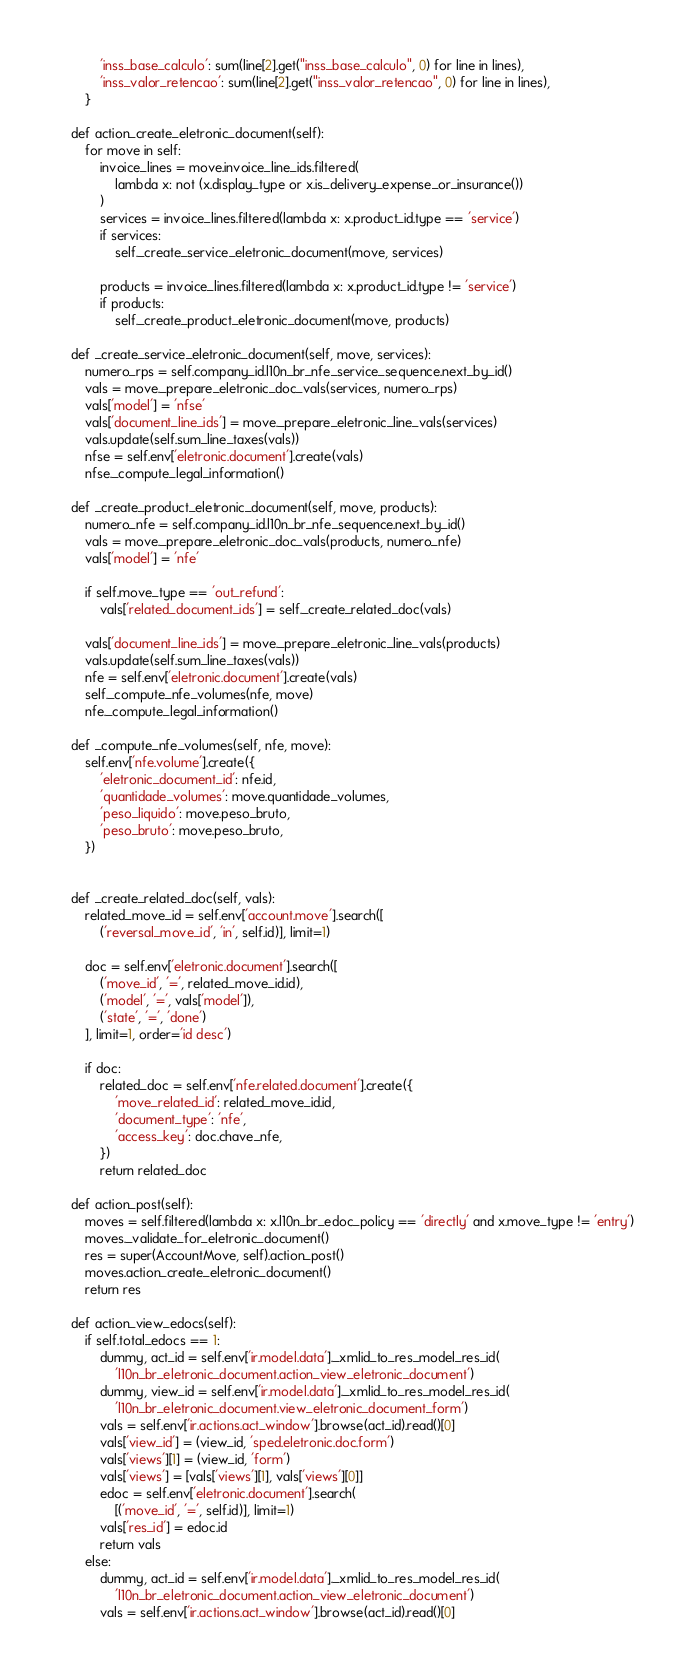Convert code to text. <code><loc_0><loc_0><loc_500><loc_500><_Python_>            'inss_base_calculo': sum(line[2].get("inss_base_calculo", 0) for line in lines),
            'inss_valor_retencao': sum(line[2].get("inss_valor_retencao", 0) for line in lines),
        }

    def action_create_eletronic_document(self):
        for move in self:
            invoice_lines = move.invoice_line_ids.filtered(
                lambda x: not (x.display_type or x.is_delivery_expense_or_insurance())
            )
            services = invoice_lines.filtered(lambda x: x.product_id.type == 'service')
            if services:
                self._create_service_eletronic_document(move, services)

            products = invoice_lines.filtered(lambda x: x.product_id.type != 'service')
            if products:
                self._create_product_eletronic_document(move, products)

    def _create_service_eletronic_document(self, move, services):
        numero_rps = self.company_id.l10n_br_nfe_service_sequence.next_by_id()
        vals = move._prepare_eletronic_doc_vals(services, numero_rps)
        vals['model'] = 'nfse'
        vals['document_line_ids'] = move._prepare_eletronic_line_vals(services)
        vals.update(self.sum_line_taxes(vals))
        nfse = self.env['eletronic.document'].create(vals)
        nfse._compute_legal_information()

    def _create_product_eletronic_document(self, move, products):
        numero_nfe = self.company_id.l10n_br_nfe_sequence.next_by_id()
        vals = move._prepare_eletronic_doc_vals(products, numero_nfe)
        vals['model'] = 'nfe'

        if self.move_type == 'out_refund':
            vals['related_document_ids'] = self._create_related_doc(vals)

        vals['document_line_ids'] = move._prepare_eletronic_line_vals(products)
        vals.update(self.sum_line_taxes(vals))
        nfe = self.env['eletronic.document'].create(vals)
        self._compute_nfe_volumes(nfe, move)
        nfe._compute_legal_information()

    def _compute_nfe_volumes(self, nfe, move):
        self.env['nfe.volume'].create({
            'eletronic_document_id': nfe.id,
            'quantidade_volumes': move.quantidade_volumes,
            'peso_liquido': move.peso_bruto,
            'peso_bruto': move.peso_bruto,
        })


    def _create_related_doc(self, vals):
        related_move_id = self.env['account.move'].search([
            ('reversal_move_id', 'in', self.id)], limit=1)

        doc = self.env['eletronic.document'].search([
            ('move_id', '=', related_move_id.id),
            ('model', '=', vals['model']),
            ('state', '=', 'done')
        ], limit=1, order='id desc')

        if doc:
            related_doc = self.env['nfe.related.document'].create({
                'move_related_id': related_move_id.id,
                'document_type': 'nfe',
                'access_key': doc.chave_nfe,
            })
            return related_doc

    def action_post(self):
        moves = self.filtered(lambda x: x.l10n_br_edoc_policy == 'directly' and x.move_type != 'entry')
        moves._validate_for_eletronic_document()
        res = super(AccountMove, self).action_post()
        moves.action_create_eletronic_document()
        return res

    def action_view_edocs(self):
        if self.total_edocs == 1:
            dummy, act_id = self.env['ir.model.data']._xmlid_to_res_model_res_id(
                'l10n_br_eletronic_document.action_view_eletronic_document')
            dummy, view_id = self.env['ir.model.data']._xmlid_to_res_model_res_id(
                'l10n_br_eletronic_document.view_eletronic_document_form')
            vals = self.env['ir.actions.act_window'].browse(act_id).read()[0]
            vals['view_id'] = (view_id, 'sped.eletronic.doc.form')
            vals['views'][1] = (view_id, 'form')
            vals['views'] = [vals['views'][1], vals['views'][0]]
            edoc = self.env['eletronic.document'].search(
                [('move_id', '=', self.id)], limit=1)
            vals['res_id'] = edoc.id
            return vals
        else:
            dummy, act_id = self.env['ir.model.data']._xmlid_to_res_model_res_id(
                'l10n_br_eletronic_document.action_view_eletronic_document')
            vals = self.env['ir.actions.act_window'].browse(act_id).read()[0]</code> 